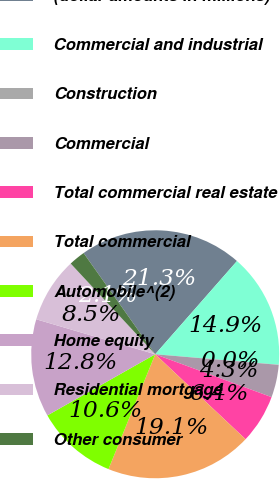Convert chart. <chart><loc_0><loc_0><loc_500><loc_500><pie_chart><fcel>(dollar amounts in millions)<fcel>Commercial and industrial<fcel>Construction<fcel>Commercial<fcel>Total commercial real estate<fcel>Total commercial<fcel>Automobile^(2)<fcel>Home equity<fcel>Residential mortgage<fcel>Other consumer<nl><fcel>21.26%<fcel>14.89%<fcel>0.01%<fcel>4.26%<fcel>6.39%<fcel>19.14%<fcel>10.64%<fcel>12.76%<fcel>8.51%<fcel>2.14%<nl></chart> 